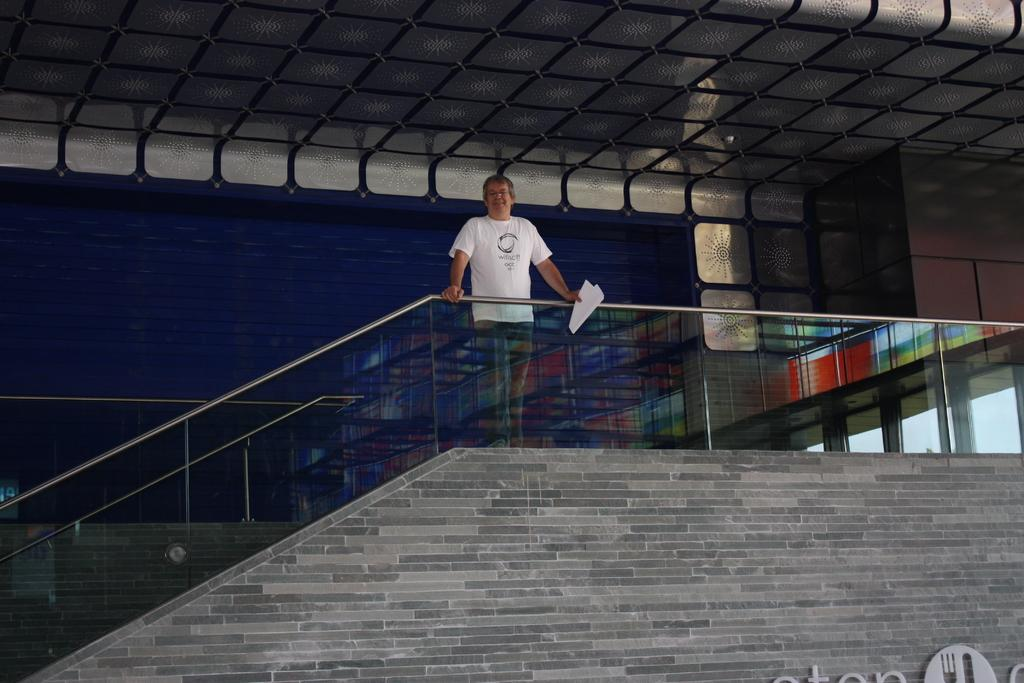What type of structure is visible in the image? There is a building in the image. What can be seen near the building? There are stairs in the image. Who is present in the image? There is a man in the image. What is the man wearing? The man is wearing a white t-shirt. What is the man holding in the image? The man is holding papers. Is the man in the image a spy, and what type of hook is he using to climb the building? There is no indication in the image that the man is a spy, nor is there any hook visible for climbing the building. 